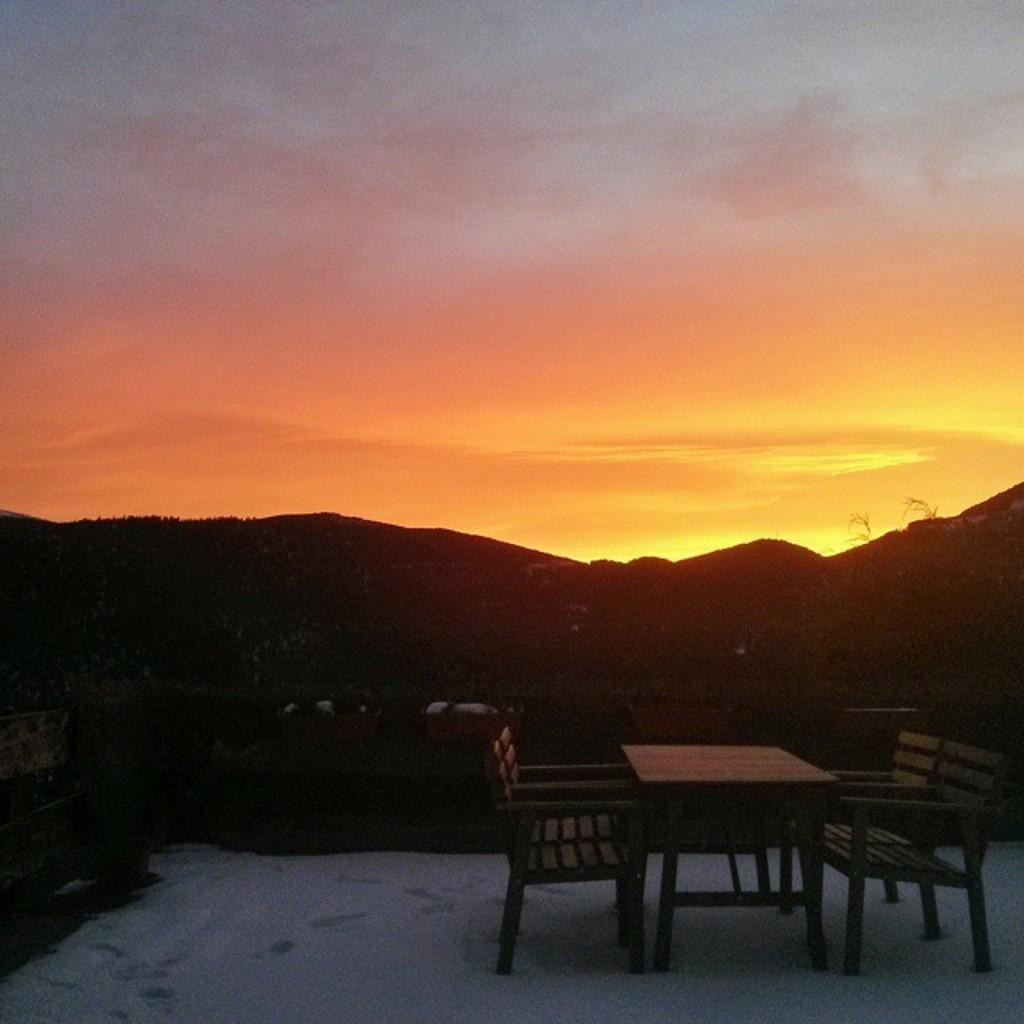Could you give a brief overview of what you see in this image? In this image I can see a table and benches in the front. There are mountains at the back and there is sky at the top. 